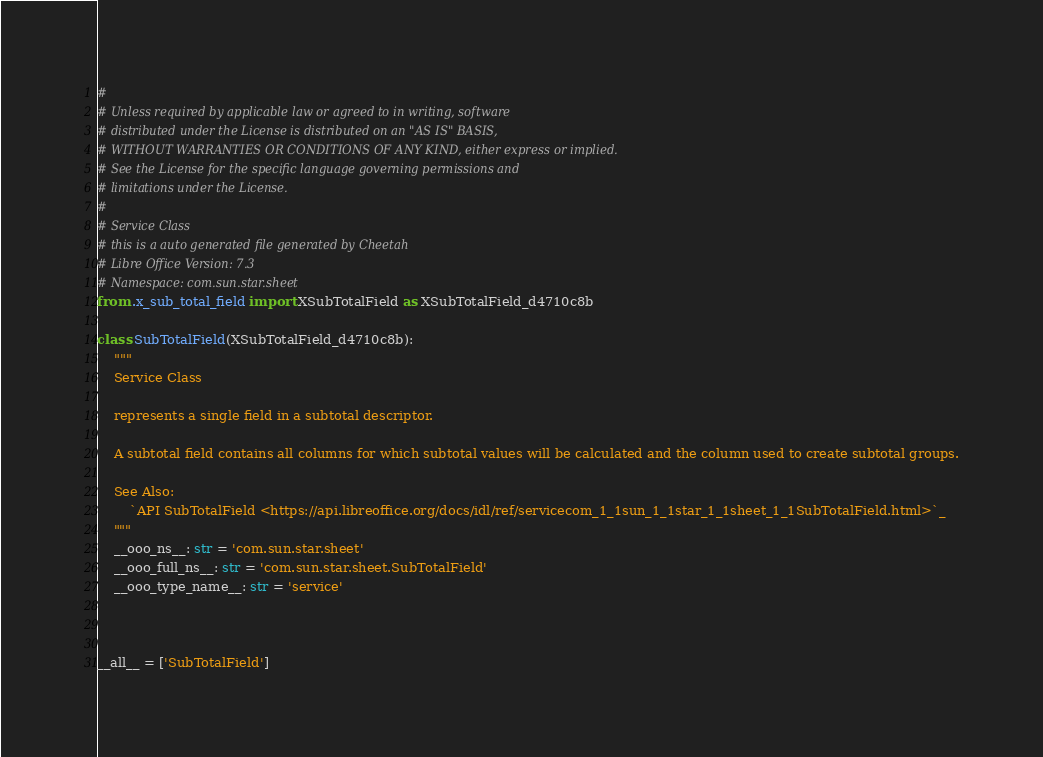<code> <loc_0><loc_0><loc_500><loc_500><_Python_>#
# Unless required by applicable law or agreed to in writing, software
# distributed under the License is distributed on an "AS IS" BASIS,
# WITHOUT WARRANTIES OR CONDITIONS OF ANY KIND, either express or implied.
# See the License for the specific language governing permissions and
# limitations under the License.
#
# Service Class
# this is a auto generated file generated by Cheetah
# Libre Office Version: 7.3
# Namespace: com.sun.star.sheet
from .x_sub_total_field import XSubTotalField as XSubTotalField_d4710c8b

class SubTotalField(XSubTotalField_d4710c8b):
    """
    Service Class

    represents a single field in a subtotal descriptor.
    
    A subtotal field contains all columns for which subtotal values will be calculated and the column used to create subtotal groups.

    See Also:
        `API SubTotalField <https://api.libreoffice.org/docs/idl/ref/servicecom_1_1sun_1_1star_1_1sheet_1_1SubTotalField.html>`_
    """
    __ooo_ns__: str = 'com.sun.star.sheet'
    __ooo_full_ns__: str = 'com.sun.star.sheet.SubTotalField'
    __ooo_type_name__: str = 'service'



__all__ = ['SubTotalField']

</code> 